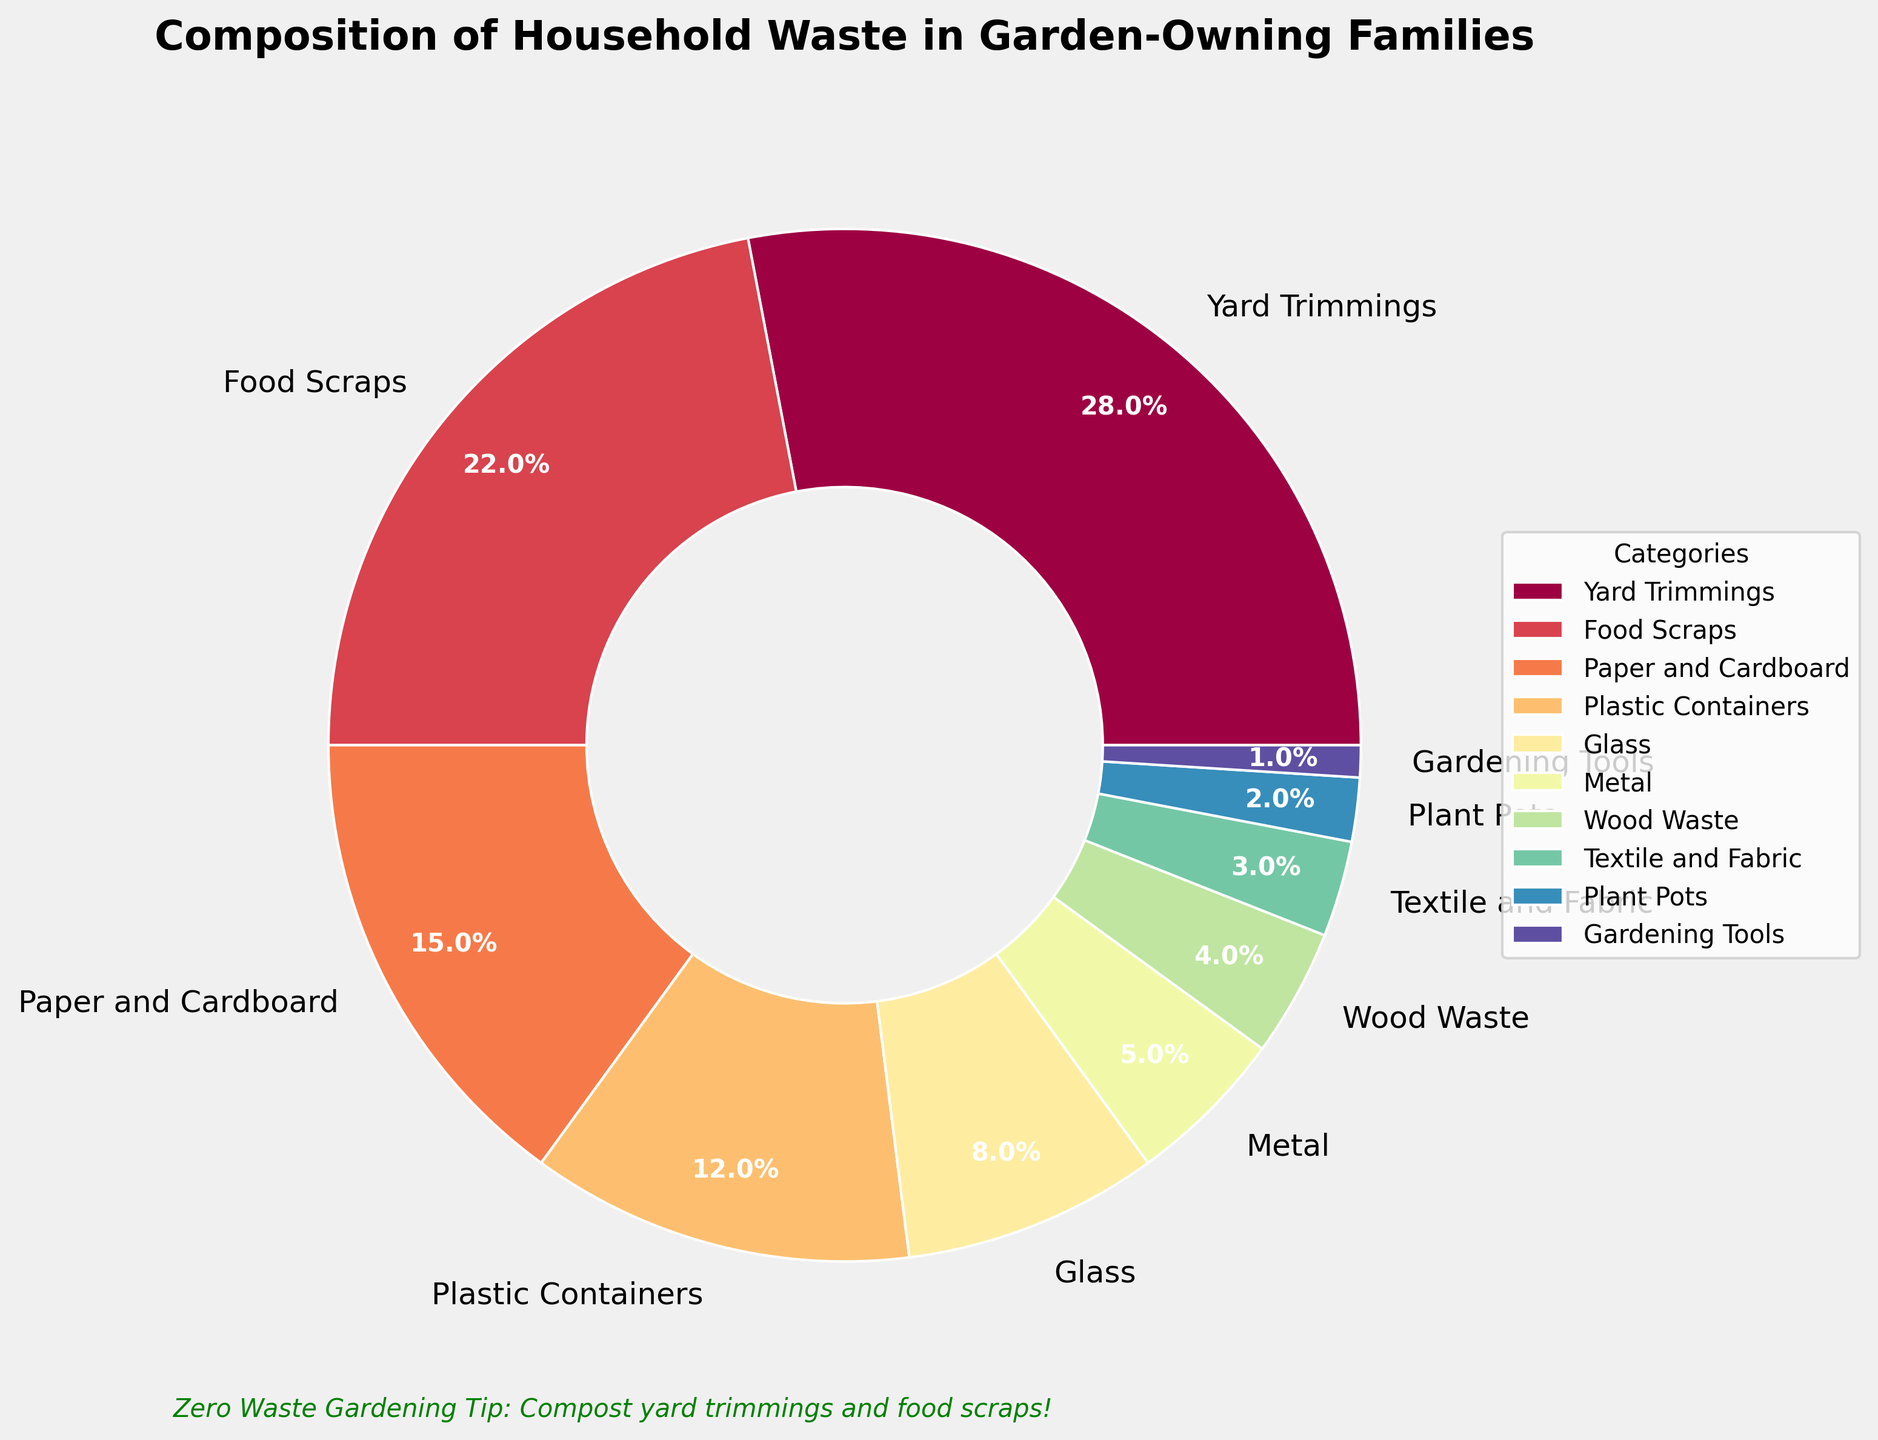What percentage of household waste is made up of yard trimmings and food scraps combined? Yard trimmings make up 28% and food scraps make up 22%. Adding these two percentages together gives 28% + 22% = 50%.
Answer: 50% Which category contributes the smallest percentage to household waste? The chart shows that gardening tools contribute only 1%, which is the smallest percentage among all categories.
Answer: Gardening tools How much more percentage does yard trimmings contribute compared to plastic containers? Yard trimmings contribute 28% while plastic containers contribute 12%. Subtracting these gives 28% - 12% = 16%.
Answer: 16% What is the total percentage of waste composed of glass, metal, and textile and fabric? Glass makes up 8%, metal makes up 5%, and textile and fabric make up 3%. Adding these together gives 8% + 5% + 3% = 16%.
Answer: 16% Which categories contribute more than 20% of household waste? Referring to the chart, only yard trimmings (28%) and food scraps (22%) contribute more than 20%.
Answer: Yard trimmings and food scraps Is the percentage of wood waste more or less than plant pots? The chart shows wood waste at 4% and plant pots at 2%, so wood waste is more.
Answer: More Compare and mention the difference in percentage between the highest and the lowest category. The highest category is yard trimmings at 28%, and the lowest category is gardening tools at 1%. The difference is 28% - 1% = 27%.
Answer: 27% What percentage of waste is made up of paper and cardboard plus plastic containers? Paper and cardboard contribute 15%, and plastic containers contribute 12%. Adding these together gives 15% + 12% = 27%.
Answer: 27% How does the waste percentage of food scraps compare to that of paper and cardboard? Food scraps account for 22% and paper and cardboard for 15%. Therefore, food scraps are greater by 22% - 15% = 7%.
Answer: 7% What color represents the textile and fabric category in the pie chart? Given the color scheme (not visually available here), referring to a typical Spectral colormap, textile and fabric might be represented by a distinct color, but specifics need the chart.
Answer: (Check chart) 